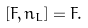Convert formula to latex. <formula><loc_0><loc_0><loc_500><loc_500>[ F , n _ { L } ] = F .</formula> 